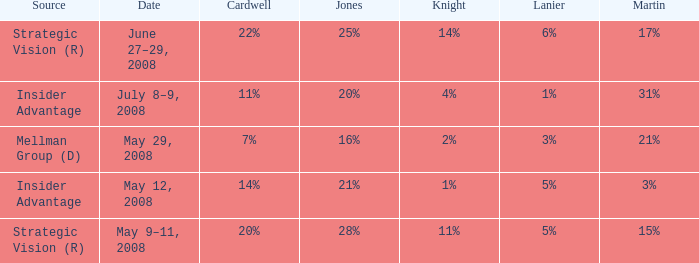What source has a cardwell of 20%? Strategic Vision (R). 